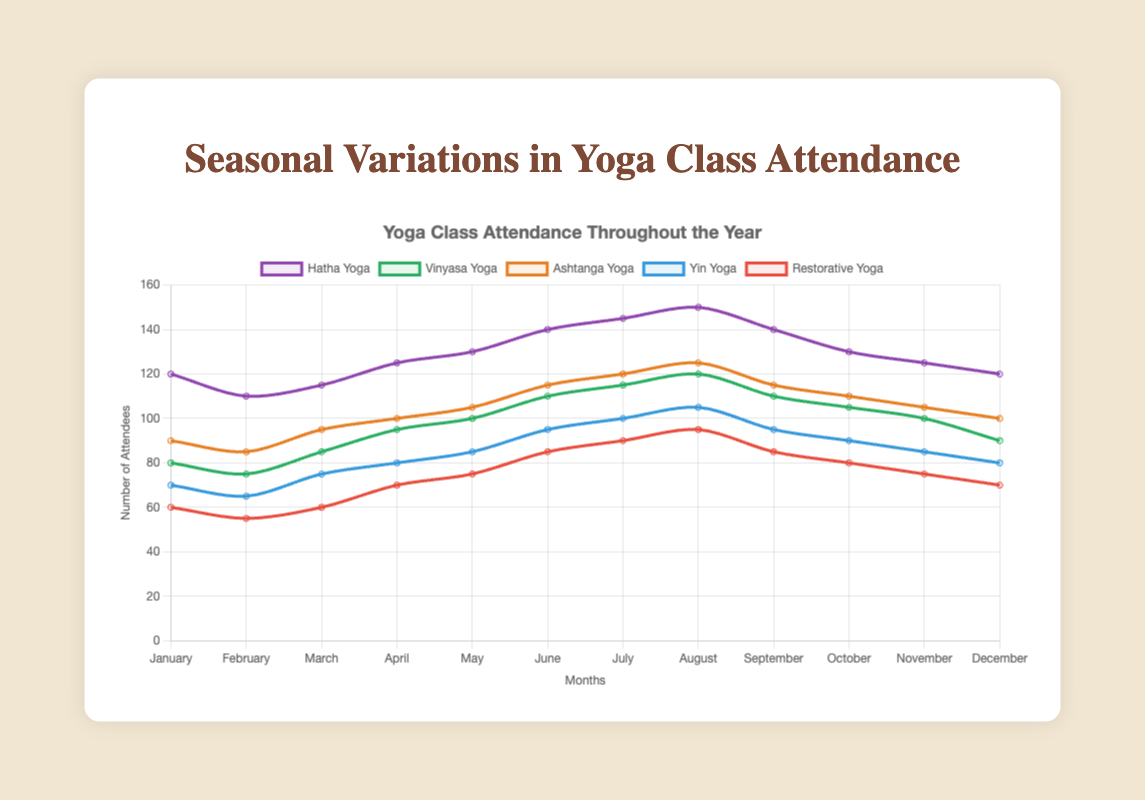Which type of yoga reached the peak attendance during the year? By inspecting the peaks of each line, we see that Hatha Yoga reaches the highest attendance of 150 attendees in August.
Answer: Hatha Yoga How does the attendance of Vinyasa Yoga in March compare to its attendance in November? Referring to the figure, Vinyasa Yoga had 85 attendees in March and 100 attendees in November.
Answer: November attendance is higher What is the average attendance for Yin Yoga throughout the year? The monthly attendance figures for Yin Yoga are [70, 65, 75, 80, 85, 95, 100, 105, 95, 90, 85, 80]. Adding these values and dividing by 12 gives an average of (70+65+75+80+85+95+100+105+95+90+85+80)/12 = 85
Answer: 85 Which two months show the greatest increase in attendance for Restorative Yoga? To find this, look at the differences between consecutive months. The largest increase is between April (60 attendees) and May (70 attendees) with an increase of 10 attendees. The second largest is between May (70) and June (85) with an increase of 15 attendees.
Answer: April to May, May to June How does the trend in Ashtanga Yoga attendance differ from the trend in Restorative Yoga attendance? Ashtanga Yoga has a consistent increase from January to August, followed by a gradual decrease until December. Restorative Yoga has a more fluctuating pattern with a noticeable increase from May to August and a decrease from September to December.
Answer: Consistent increase then gradual decrease vs fluctuating pattern In which month does Hatha Yoga attendance start to decline after reaching its peak? The peak for Hatha Yoga is in August with 150 attendees, and it starts declining in September with 140 attendees.
Answer: September What is the difference in attendance between the most popular and the least popular type of yoga class in July? In July, Hatha Yoga has the highest attendance with 145 attendees, and Restorative Yoga has the lowest with 90 attendees. The difference is 145 - 90 = 55.
Answer: 55 Which type of yoga has the smallest variation in attendance throughout the year? By visually inspecting the lines, Ashtanga Yoga seems to show the least variation, ranging from 85 to 125 attendees. This can be confirmed by calculating the range for each type of yoga.
Answer: Ashtanga Yoga Comparing October's data, which yoga type has almost the same number of attendees? In October, Hatha Yoga has 130, Vinyasa Yoga has 105, Ashtanga Yoga has 110, Yin Yoga has 90, Restorative Yoga has 80. Ashtanga and Vinyasa Yoga have the closest with a difference of 105 to 110.
Answer: Ashtanga Yoga and Vinyasa Yoga How do the attendance patterns of Hatha Yoga and Yin Yoga compare from January to June? From January to June, Hatha Yoga shows a steady increase from 120 to 140 attendees. Yin Yoga also shows an increasing trend during the same period, going from 70 to 95 attendees, though the increase is less steep compared to Hatha Yoga.
Answer: Hatha Yoga increases more steeply 